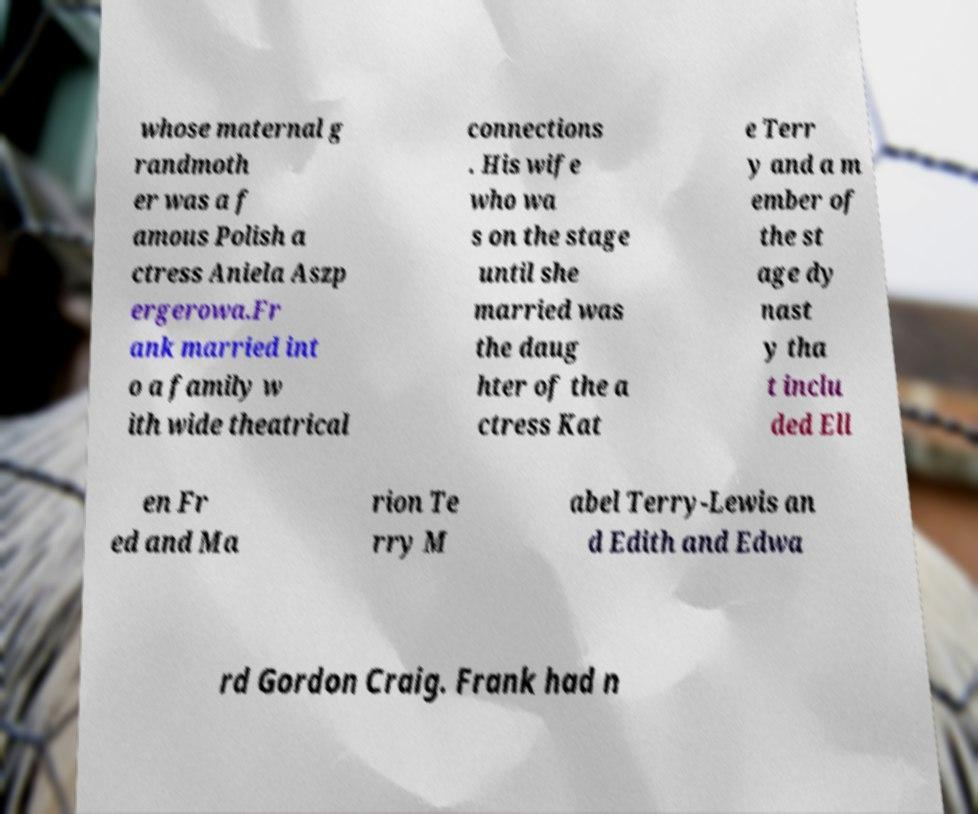For documentation purposes, I need the text within this image transcribed. Could you provide that? whose maternal g randmoth er was a f amous Polish a ctress Aniela Aszp ergerowa.Fr ank married int o a family w ith wide theatrical connections . His wife who wa s on the stage until she married was the daug hter of the a ctress Kat e Terr y and a m ember of the st age dy nast y tha t inclu ded Ell en Fr ed and Ma rion Te rry M abel Terry-Lewis an d Edith and Edwa rd Gordon Craig. Frank had n 